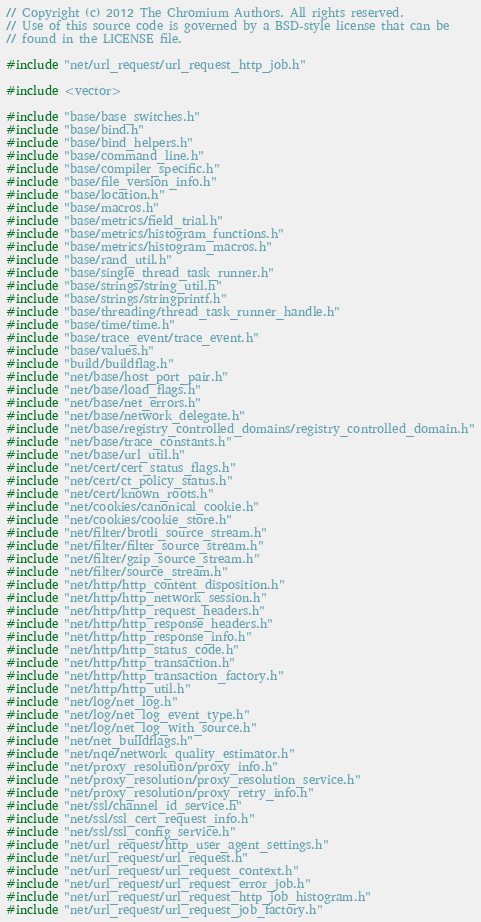Convert code to text. <code><loc_0><loc_0><loc_500><loc_500><_C++_>// Copyright (c) 2012 The Chromium Authors. All rights reserved.
// Use of this source code is governed by a BSD-style license that can be
// found in the LICENSE file.

#include "net/url_request/url_request_http_job.h"

#include <vector>

#include "base/base_switches.h"
#include "base/bind.h"
#include "base/bind_helpers.h"
#include "base/command_line.h"
#include "base/compiler_specific.h"
#include "base/file_version_info.h"
#include "base/location.h"
#include "base/macros.h"
#include "base/metrics/field_trial.h"
#include "base/metrics/histogram_functions.h"
#include "base/metrics/histogram_macros.h"
#include "base/rand_util.h"
#include "base/single_thread_task_runner.h"
#include "base/strings/string_util.h"
#include "base/strings/stringprintf.h"
#include "base/threading/thread_task_runner_handle.h"
#include "base/time/time.h"
#include "base/trace_event/trace_event.h"
#include "base/values.h"
#include "build/buildflag.h"
#include "net/base/host_port_pair.h"
#include "net/base/load_flags.h"
#include "net/base/net_errors.h"
#include "net/base/network_delegate.h"
#include "net/base/registry_controlled_domains/registry_controlled_domain.h"
#include "net/base/trace_constants.h"
#include "net/base/url_util.h"
#include "net/cert/cert_status_flags.h"
#include "net/cert/ct_policy_status.h"
#include "net/cert/known_roots.h"
#include "net/cookies/canonical_cookie.h"
#include "net/cookies/cookie_store.h"
#include "net/filter/brotli_source_stream.h"
#include "net/filter/filter_source_stream.h"
#include "net/filter/gzip_source_stream.h"
#include "net/filter/source_stream.h"
#include "net/http/http_content_disposition.h"
#include "net/http/http_network_session.h"
#include "net/http/http_request_headers.h"
#include "net/http/http_response_headers.h"
#include "net/http/http_response_info.h"
#include "net/http/http_status_code.h"
#include "net/http/http_transaction.h"
#include "net/http/http_transaction_factory.h"
#include "net/http/http_util.h"
#include "net/log/net_log.h"
#include "net/log/net_log_event_type.h"
#include "net/log/net_log_with_source.h"
#include "net/net_buildflags.h"
#include "net/nqe/network_quality_estimator.h"
#include "net/proxy_resolution/proxy_info.h"
#include "net/proxy_resolution/proxy_resolution_service.h"
#include "net/proxy_resolution/proxy_retry_info.h"
#include "net/ssl/channel_id_service.h"
#include "net/ssl/ssl_cert_request_info.h"
#include "net/ssl/ssl_config_service.h"
#include "net/url_request/http_user_agent_settings.h"
#include "net/url_request/url_request.h"
#include "net/url_request/url_request_context.h"
#include "net/url_request/url_request_error_job.h"
#include "net/url_request/url_request_http_job_histogram.h"
#include "net/url_request/url_request_job_factory.h"</code> 